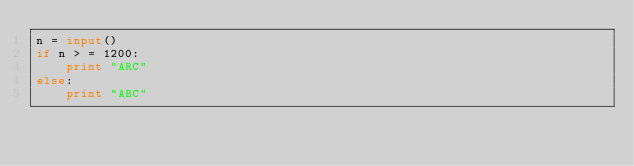Convert code to text. <code><loc_0><loc_0><loc_500><loc_500><_Python_>n = input()
if n > = 1200:
    print "ARC"
else:
    print "ABC"</code> 